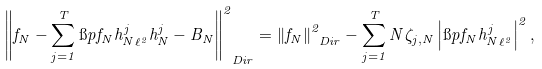<formula> <loc_0><loc_0><loc_500><loc_500>\left \| f _ { N } - \sum _ { j = 1 } ^ { T } \i p { f _ { N } } { h _ { N } ^ { j } } _ { \ell ^ { 2 } } h _ { N } ^ { j } - B _ { N } \right \| _ { \ D i r } ^ { 2 } = \left \| f _ { N } \right \| ^ { 2 } _ { \ D i r } - \sum _ { j = 1 } ^ { T } N \zeta _ { j , N } \left | \i p { f _ { N } } { h _ { N } ^ { j } } _ { \ell ^ { 2 } } \right | ^ { 2 } ,</formula> 